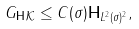Convert formula to latex. <formula><loc_0><loc_0><loc_500><loc_500>\| G _ { \mathbf H } \| _ { \mathcal { K } } \leq C ( \sigma ) \| { \mathbf H } \| _ { L ^ { 2 } ( \sigma ) ^ { 2 } } ,</formula> 